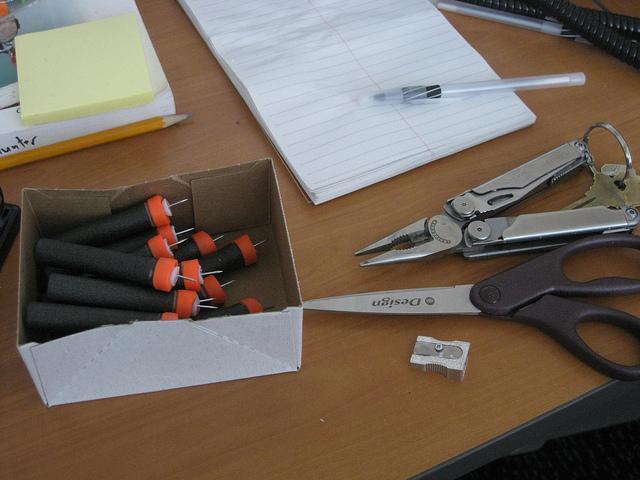How many writing utensils are in the photo?
Give a very brief answer. 2. How many books are there?
Give a very brief answer. 2. 